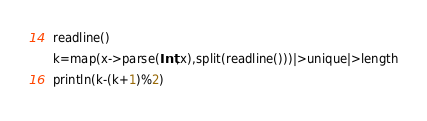<code> <loc_0><loc_0><loc_500><loc_500><_Julia_>readline()
k=map(x->parse(Int,x),split(readline()))|>unique|>length
println(k-(k+1)%2)</code> 